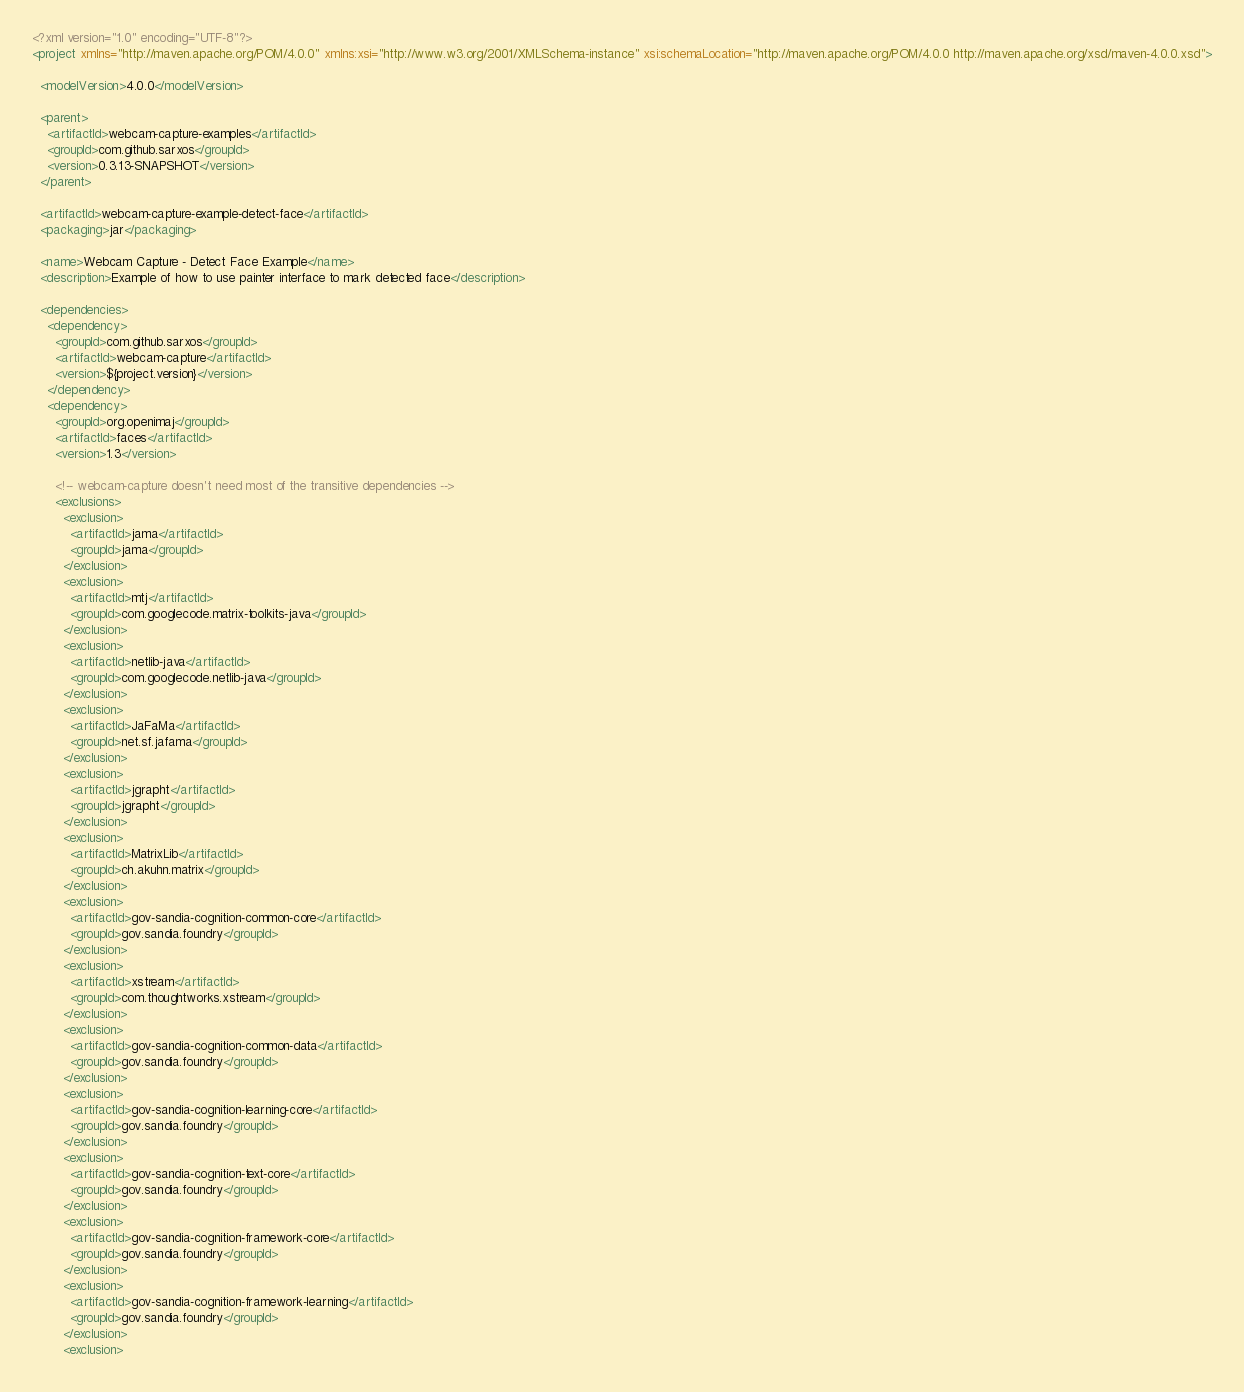<code> <loc_0><loc_0><loc_500><loc_500><_XML_><?xml version="1.0" encoding="UTF-8"?>
<project xmlns="http://maven.apache.org/POM/4.0.0" xmlns:xsi="http://www.w3.org/2001/XMLSchema-instance" xsi:schemaLocation="http://maven.apache.org/POM/4.0.0 http://maven.apache.org/xsd/maven-4.0.0.xsd">

  <modelVersion>4.0.0</modelVersion>

  <parent>
    <artifactId>webcam-capture-examples</artifactId>
    <groupId>com.github.sarxos</groupId>
    <version>0.3.13-SNAPSHOT</version>
  </parent>

  <artifactId>webcam-capture-example-detect-face</artifactId>
  <packaging>jar</packaging>

  <name>Webcam Capture - Detect Face Example</name>
  <description>Example of how to use painter interface to mark detected face</description>

  <dependencies>
    <dependency>
      <groupId>com.github.sarxos</groupId>
      <artifactId>webcam-capture</artifactId>
      <version>${project.version}</version>
    </dependency>
    <dependency>
      <groupId>org.openimaj</groupId>
      <artifactId>faces</artifactId>
      <version>1.3</version>

      <!-- webcam-capture doesn't need most of the transitive dependencies -->
      <exclusions>
        <exclusion>
          <artifactId>jama</artifactId>
          <groupId>jama</groupId>
        </exclusion>
        <exclusion>
          <artifactId>mtj</artifactId>
          <groupId>com.googlecode.matrix-toolkits-java</groupId>
        </exclusion>
        <exclusion>
          <artifactId>netlib-java</artifactId>
          <groupId>com.googlecode.netlib-java</groupId>
        </exclusion>
        <exclusion>
          <artifactId>JaFaMa</artifactId>
          <groupId>net.sf.jafama</groupId>
        </exclusion>
        <exclusion>
          <artifactId>jgrapht</artifactId>
          <groupId>jgrapht</groupId>
        </exclusion>
        <exclusion>
          <artifactId>MatrixLib</artifactId>
          <groupId>ch.akuhn.matrix</groupId>
        </exclusion>
        <exclusion>
          <artifactId>gov-sandia-cognition-common-core</artifactId>
          <groupId>gov.sandia.foundry</groupId>
        </exclusion>
        <exclusion>
          <artifactId>xstream</artifactId>
          <groupId>com.thoughtworks.xstream</groupId>
        </exclusion>
        <exclusion>
          <artifactId>gov-sandia-cognition-common-data</artifactId>
          <groupId>gov.sandia.foundry</groupId>
        </exclusion>
        <exclusion>
          <artifactId>gov-sandia-cognition-learning-core</artifactId>
          <groupId>gov.sandia.foundry</groupId>
        </exclusion>
        <exclusion>
          <artifactId>gov-sandia-cognition-text-core</artifactId>
          <groupId>gov.sandia.foundry</groupId>
        </exclusion>
        <exclusion>
          <artifactId>gov-sandia-cognition-framework-core</artifactId>
          <groupId>gov.sandia.foundry</groupId>
        </exclusion>
        <exclusion>
          <artifactId>gov-sandia-cognition-framework-learning</artifactId>
          <groupId>gov.sandia.foundry</groupId>
        </exclusion>
        <exclusion></code> 